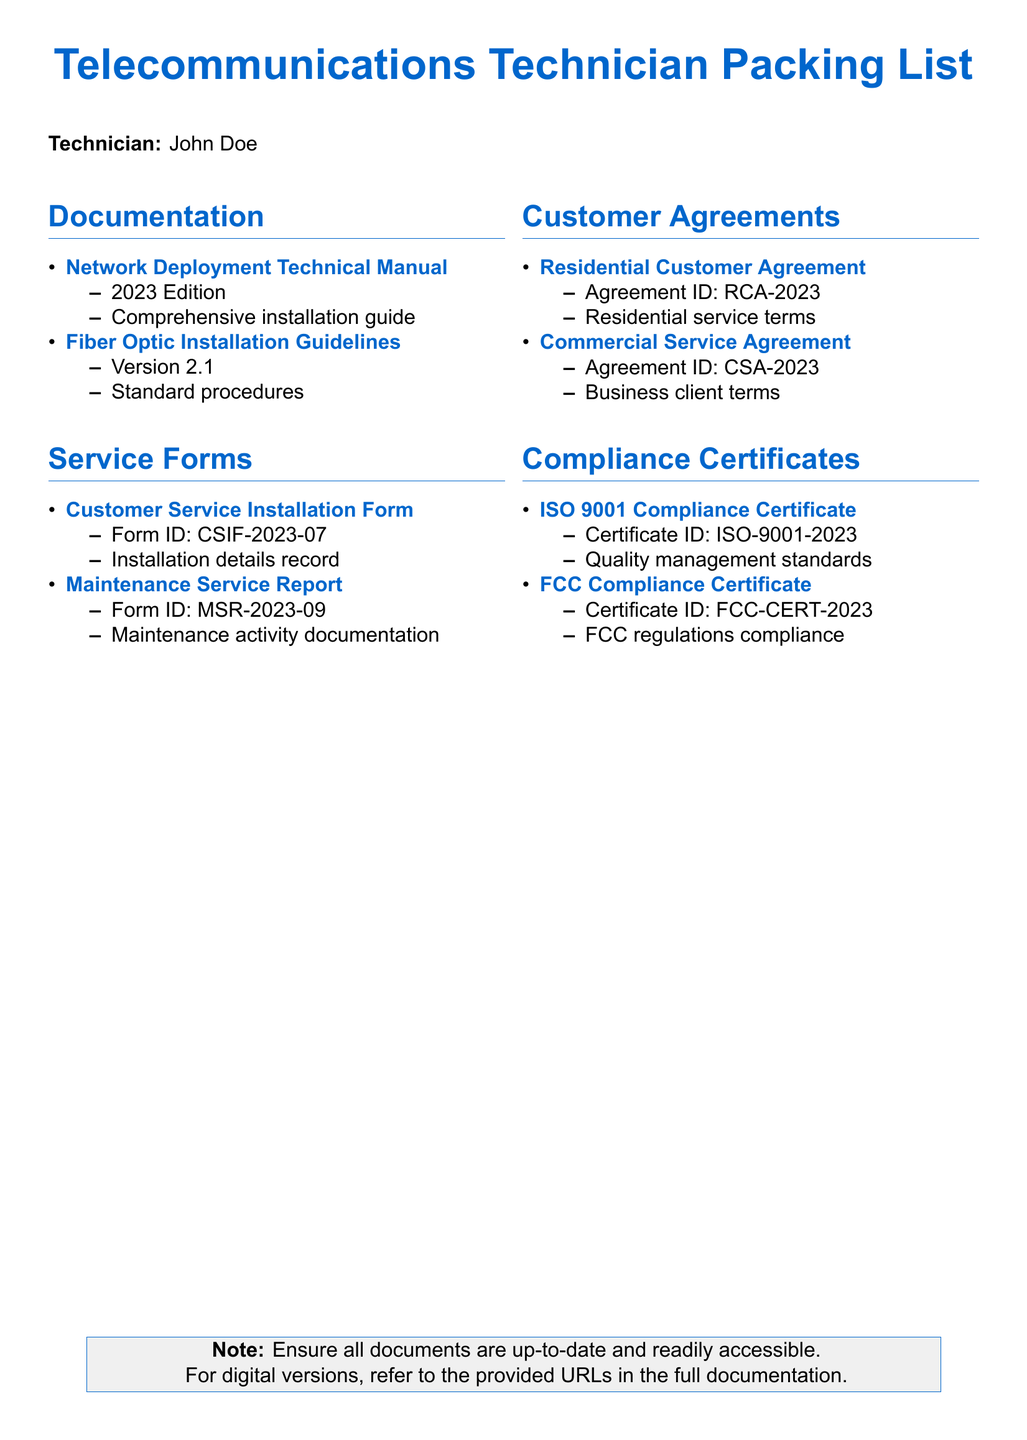What is the title of the technical manual? The title of the technical manual is provided under the documentation section, specifically listed as "Network Deployment Technical Manual."
Answer: Network Deployment Technical Manual What is the version of the Fiber Optic Installation Guidelines? The version of the Fiber Optic Installation Guidelines is mentioned in the documentation section next to its title.
Answer: Version 2.1 What is the Form ID for the Customer Service Installation Form? The Form ID for the Customer Service Installation Form is detailed in the service forms section.
Answer: CSIF-2023-07 How many compliance certificates are listed in the document? The total number of compliance certificates is calculated by counting the items in the compliance certificates section.
Answer: 2 What is the Agreement ID for the Residential Customer Agreement? The Agreement ID for the Residential Customer Agreement is specified in the customer agreements section.
Answer: RCA-2023 Which certificate ID pertains to FCC compliance? The certificate ID for FCC compliance is indicated in the compliance certificates section of the document.
Answer: FCC-CERT-2023 What type of maintenance activity is documented by the Maintenance Service Report? The type of maintenance activity is mentioned alongside the report title in the service forms section.
Answer: Maintenance activity documentation What year is the ISO 9001 Compliance Certificate from? The year of the ISO 9001 Compliance Certificate can be found in the respective listing under compliance certificates.
Answer: 2023 